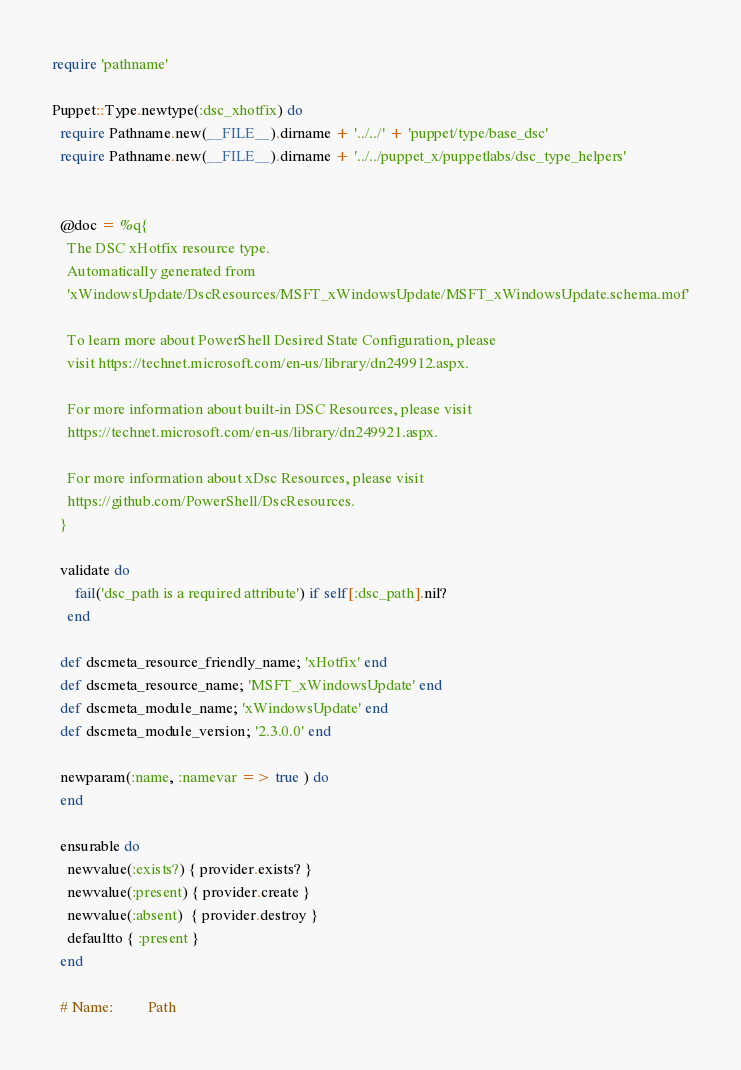<code> <loc_0><loc_0><loc_500><loc_500><_Ruby_>require 'pathname'

Puppet::Type.newtype(:dsc_xhotfix) do
  require Pathname.new(__FILE__).dirname + '../../' + 'puppet/type/base_dsc'
  require Pathname.new(__FILE__).dirname + '../../puppet_x/puppetlabs/dsc_type_helpers'


  @doc = %q{
    The DSC xHotfix resource type.
    Automatically generated from
    'xWindowsUpdate/DscResources/MSFT_xWindowsUpdate/MSFT_xWindowsUpdate.schema.mof'

    To learn more about PowerShell Desired State Configuration, please
    visit https://technet.microsoft.com/en-us/library/dn249912.aspx.

    For more information about built-in DSC Resources, please visit
    https://technet.microsoft.com/en-us/library/dn249921.aspx.

    For more information about xDsc Resources, please visit
    https://github.com/PowerShell/DscResources.
  }

  validate do
      fail('dsc_path is a required attribute') if self[:dsc_path].nil?
    end

  def dscmeta_resource_friendly_name; 'xHotfix' end
  def dscmeta_resource_name; 'MSFT_xWindowsUpdate' end
  def dscmeta_module_name; 'xWindowsUpdate' end
  def dscmeta_module_version; '2.3.0.0' end

  newparam(:name, :namevar => true ) do
  end

  ensurable do
    newvalue(:exists?) { provider.exists? }
    newvalue(:present) { provider.create }
    newvalue(:absent)  { provider.destroy }
    defaultto { :present }
  end

  # Name:         Path</code> 